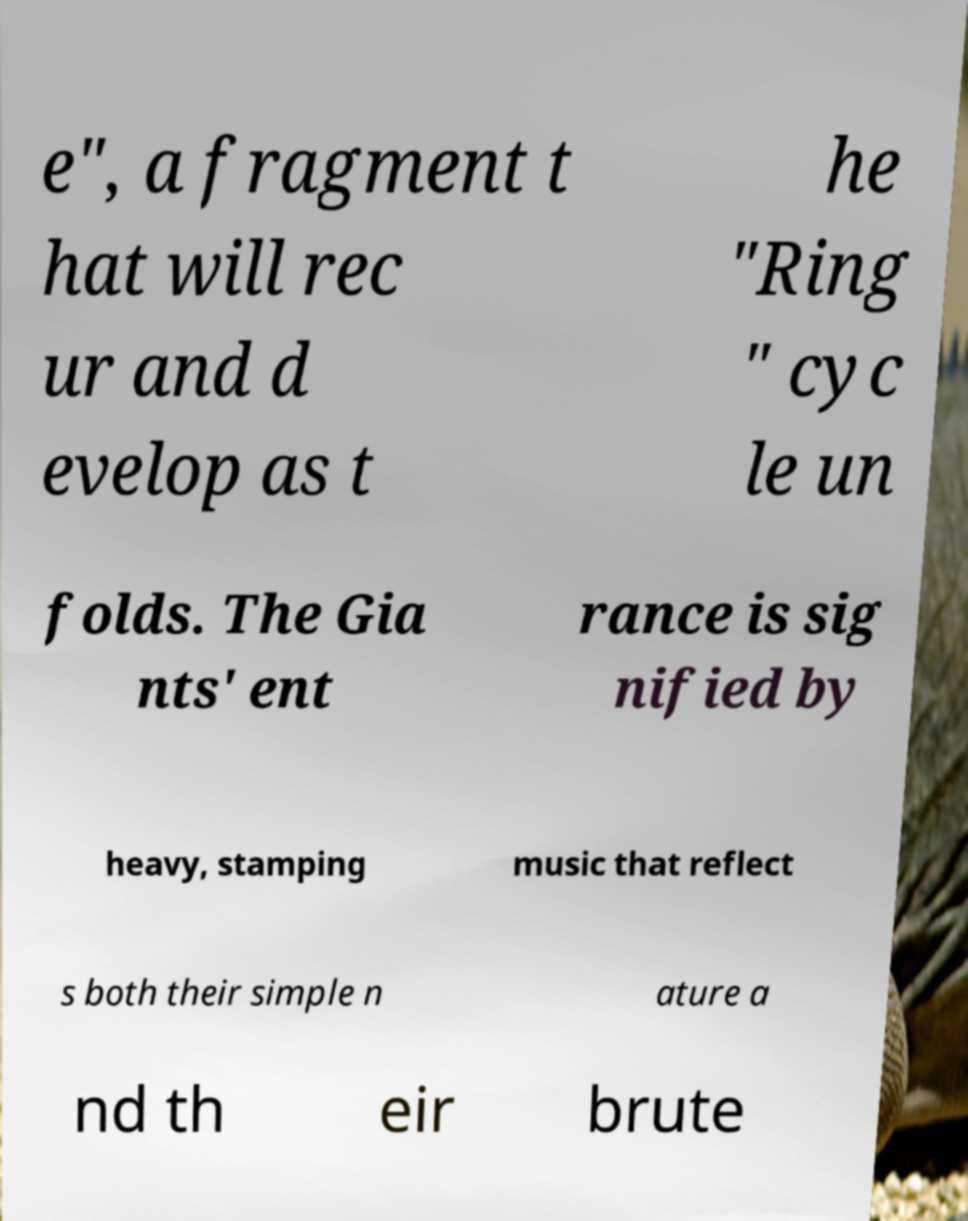What messages or text are displayed in this image? I need them in a readable, typed format. e", a fragment t hat will rec ur and d evelop as t he "Ring " cyc le un folds. The Gia nts' ent rance is sig nified by heavy, stamping music that reflect s both their simple n ature a nd th eir brute 